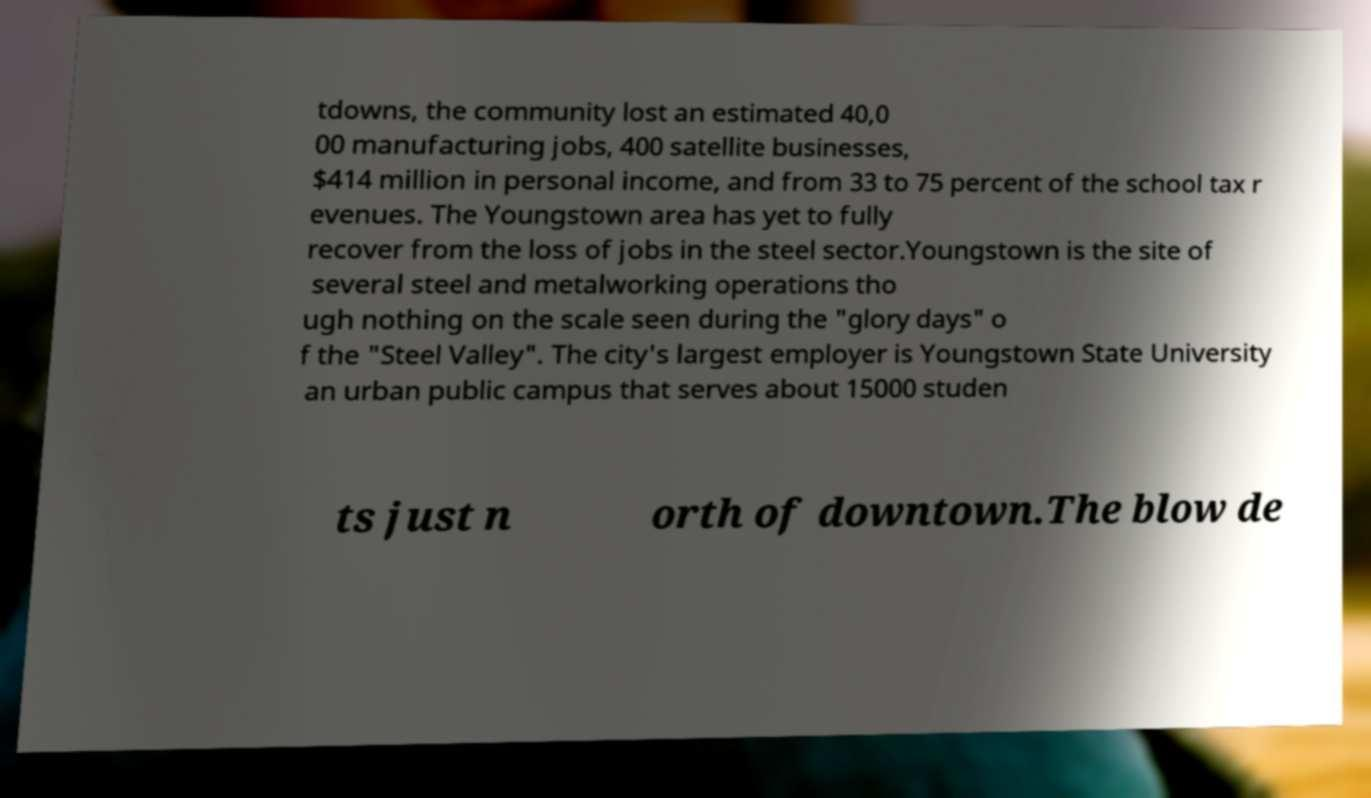I need the written content from this picture converted into text. Can you do that? tdowns, the community lost an estimated 40,0 00 manufacturing jobs, 400 satellite businesses, $414 million in personal income, and from 33 to 75 percent of the school tax r evenues. The Youngstown area has yet to fully recover from the loss of jobs in the steel sector.Youngstown is the site of several steel and metalworking operations tho ugh nothing on the scale seen during the "glory days" o f the "Steel Valley". The city's largest employer is Youngstown State University an urban public campus that serves about 15000 studen ts just n orth of downtown.The blow de 